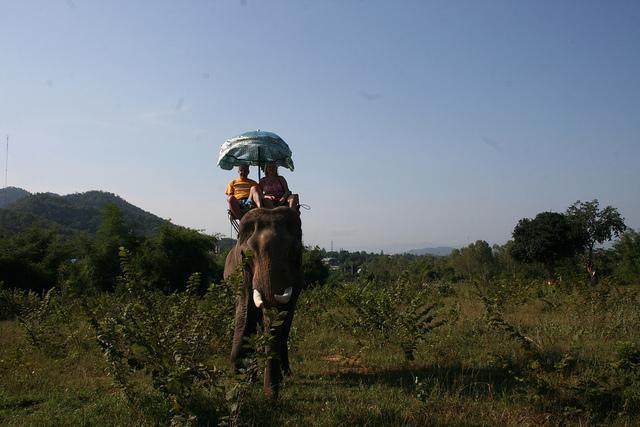How many elephants are there?
Give a very brief answer. 1. 